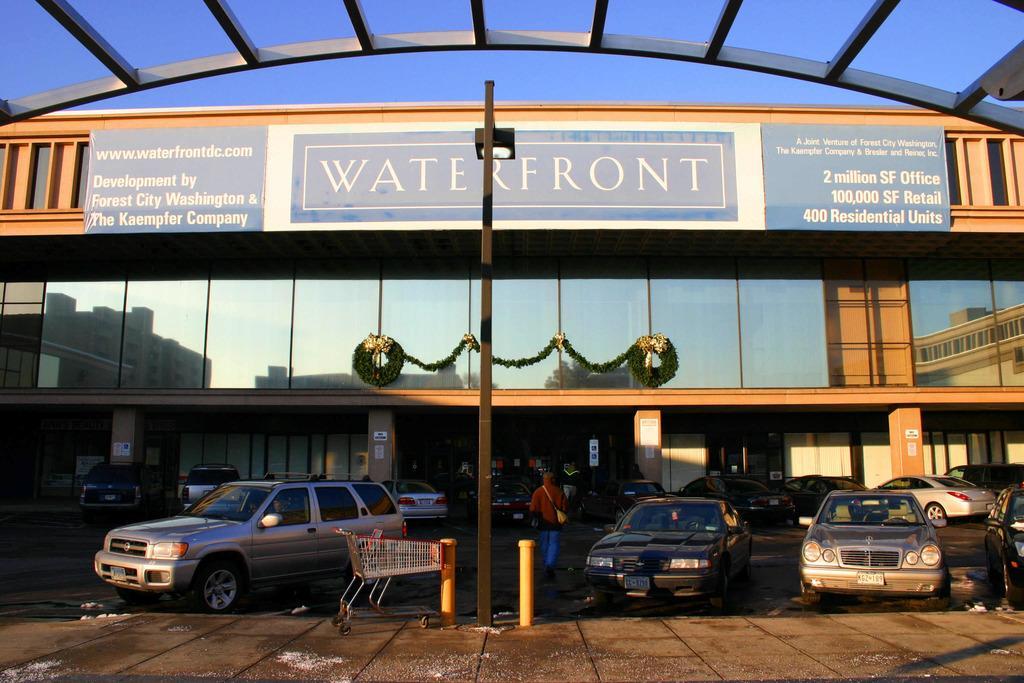Please provide a concise description of this image. In this image we can see a person walking on the ground and there are vehicles parked on the ground. And there are poles and light pole. In the background, we can see the building with board and we can see the text and numbers written on the board. At the top we can see the sky. 